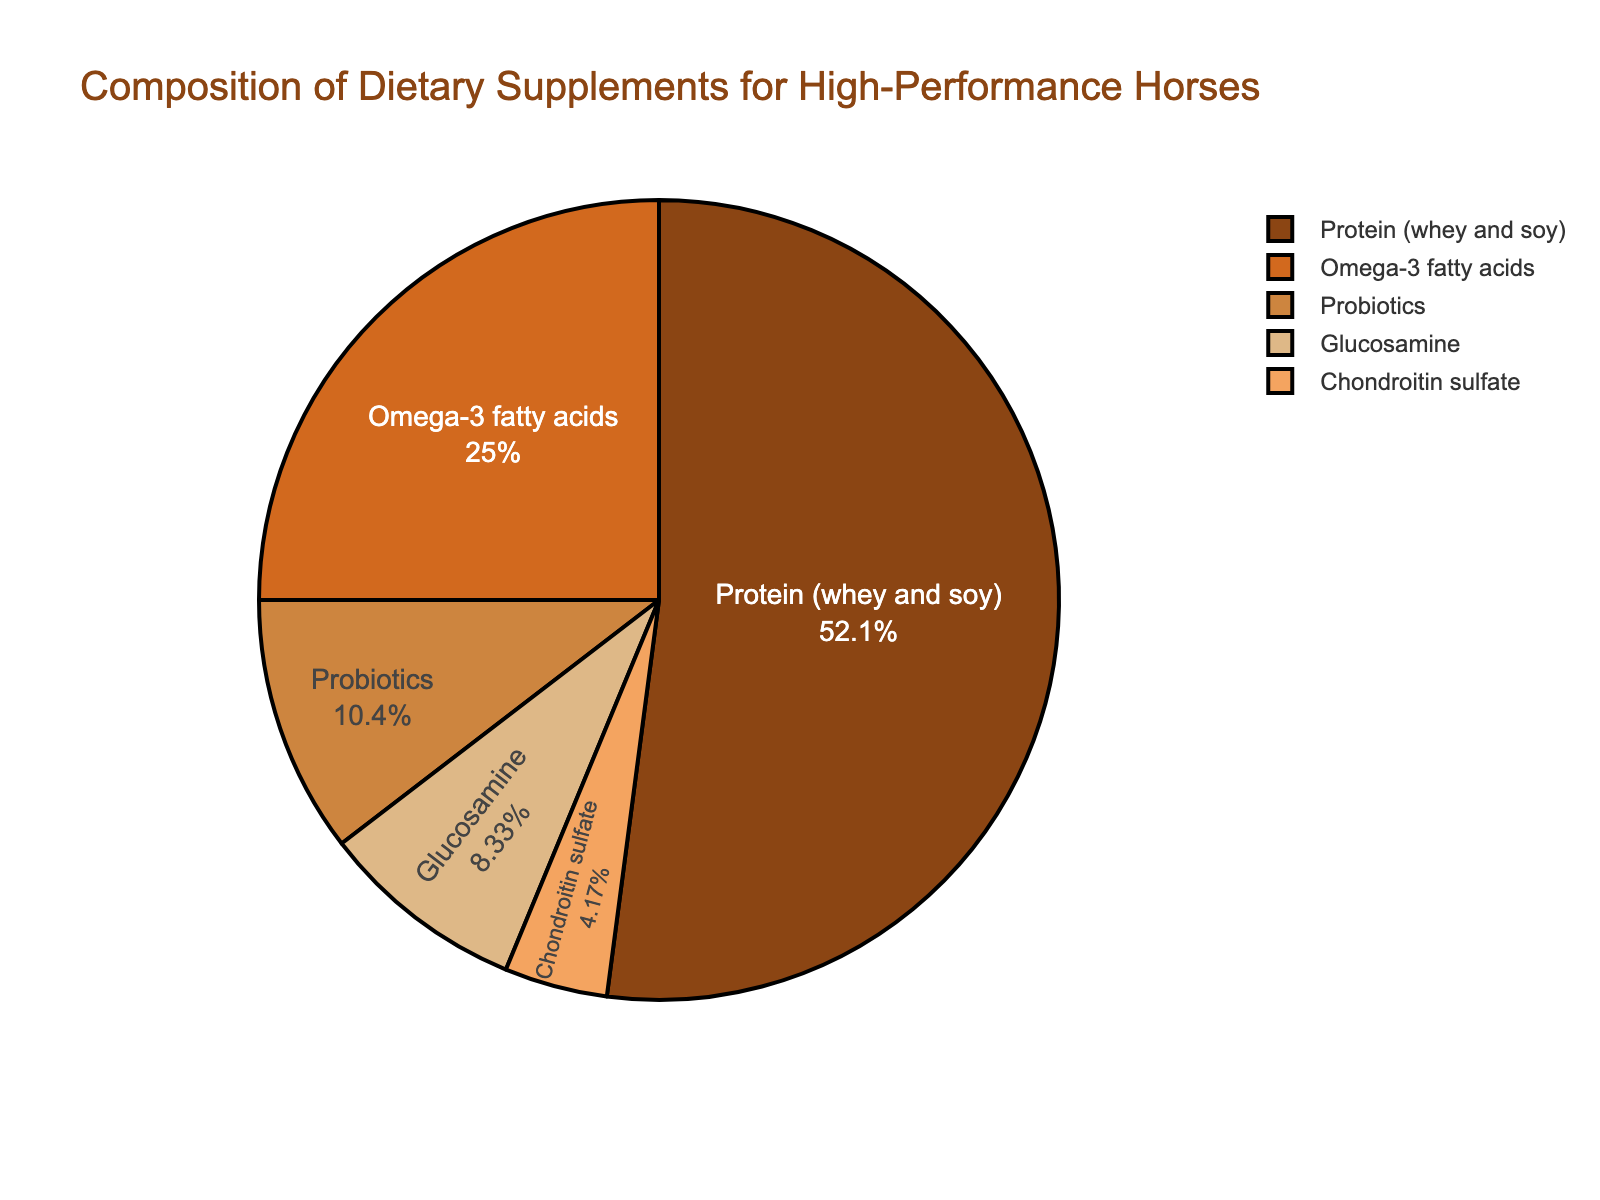What percentage of the dietary supplements is made up of Glucosamine and Chondroitin sulfate combined? To find the combined percentage, add the percentages of Glucosamine (4%) and Chondroitin sulfate (2%) together: 4 + 2 = 6.
Answer: 6% What ingredient has the highest percentage in the dietary supplements? The ingredient with the highest percentage can be identified by looking at the largest section of the pie chart, which is Protein (whey and soy) at 25%.
Answer: Protein (whey and soy) Which ingredient has a higher percentage, Omega-3 fatty acids or Probiotics, and by how much? Compare the percentages of Omega-3 fatty acids (12%) and Probiotics (5%). The difference is 12 - 5 = 7.
Answer: Omega-3 fatty acids by 7% Are Probiotics and Chondroitin sulfate combined equal to the percentage of Omega-3 fatty acids? Add the percentages of Probiotics (5%) and Chondroitin sulfate (2%) and compare it to the percentage of Omega-3 fatty acids (12%). 5 + 2 = 7, which is less than 12.
Answer: No Which ingredient has the smallest percentage in the dietary supplements? Identify the smallest section of the pie chart, which corresponds to Chondroitin sulfate at 2%.
Answer: Chondroitin sulfate What is the visual color representation of Glucosamine in the pie chart? Glucosamine is represented by a segment with a specific color in the chart. According to the color scheme, it should match one of the listed colors, notably '#DEB887'.
Answer: Sandy brown color If you combine the percentages of Omega-3 fatty acids, Probiotics, and Glucosamine, do they cover more or less than half of the total dietary supplement composition? Add the percentages: Omega-3 fatty acids (12%) + Probiotics (5%) + Glucosamine (4%) = 21%. Compare to 50%, which is half of the total. 21% is less than 50%.
Answer: Less How many times greater is the percentage of Protein (whey and soy) compared to Chondroitin sulfate? Divide the percentage of Protein (25%) by the percentage of Chondroitin sulfate (2%): 25 / 2 = 12.5.
Answer: 12.5 times Which ingredients combined make up more than one-third of the dietary supplements? Find which combinations of ingredients sum to more than 33.33%. For example, Protein (25%) + Omega-3 fatty acids (12%) = 37%. This combination exceeds one-third.
Answer: Protein and Omega-3 fatty acids If the percentage of Omega-3 fatty acids was increased by 3%, what would be the new percentage, and how would it compare to the percentage of Protein? Increase Omega-3 fatty acids by 3%: 12 + 3 = 15%. Compare with Protein (25%). 15% is still less than 25%.
Answer: 15%, still less 